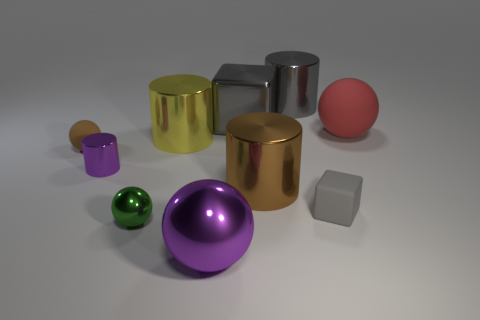Subtract all cubes. How many objects are left? 8 Subtract 0 yellow blocks. How many objects are left? 10 Subtract all shiny objects. Subtract all metal cubes. How many objects are left? 2 Add 1 gray cylinders. How many gray cylinders are left? 2 Add 6 green spheres. How many green spheres exist? 7 